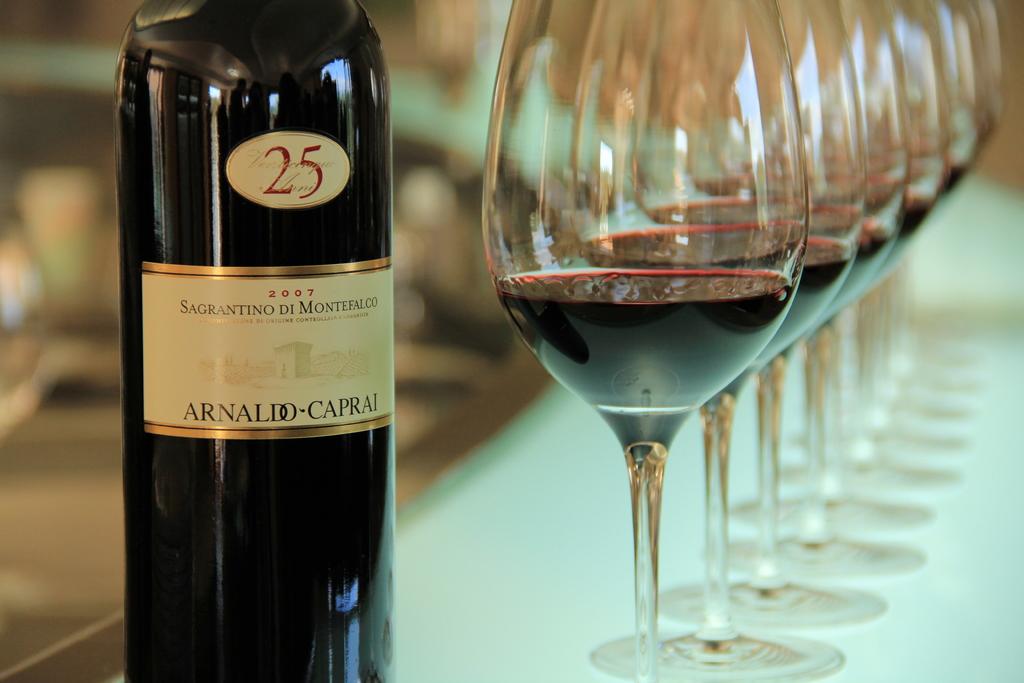What is the brand of this wine?
Make the answer very short. Arnaldo-caprai. 